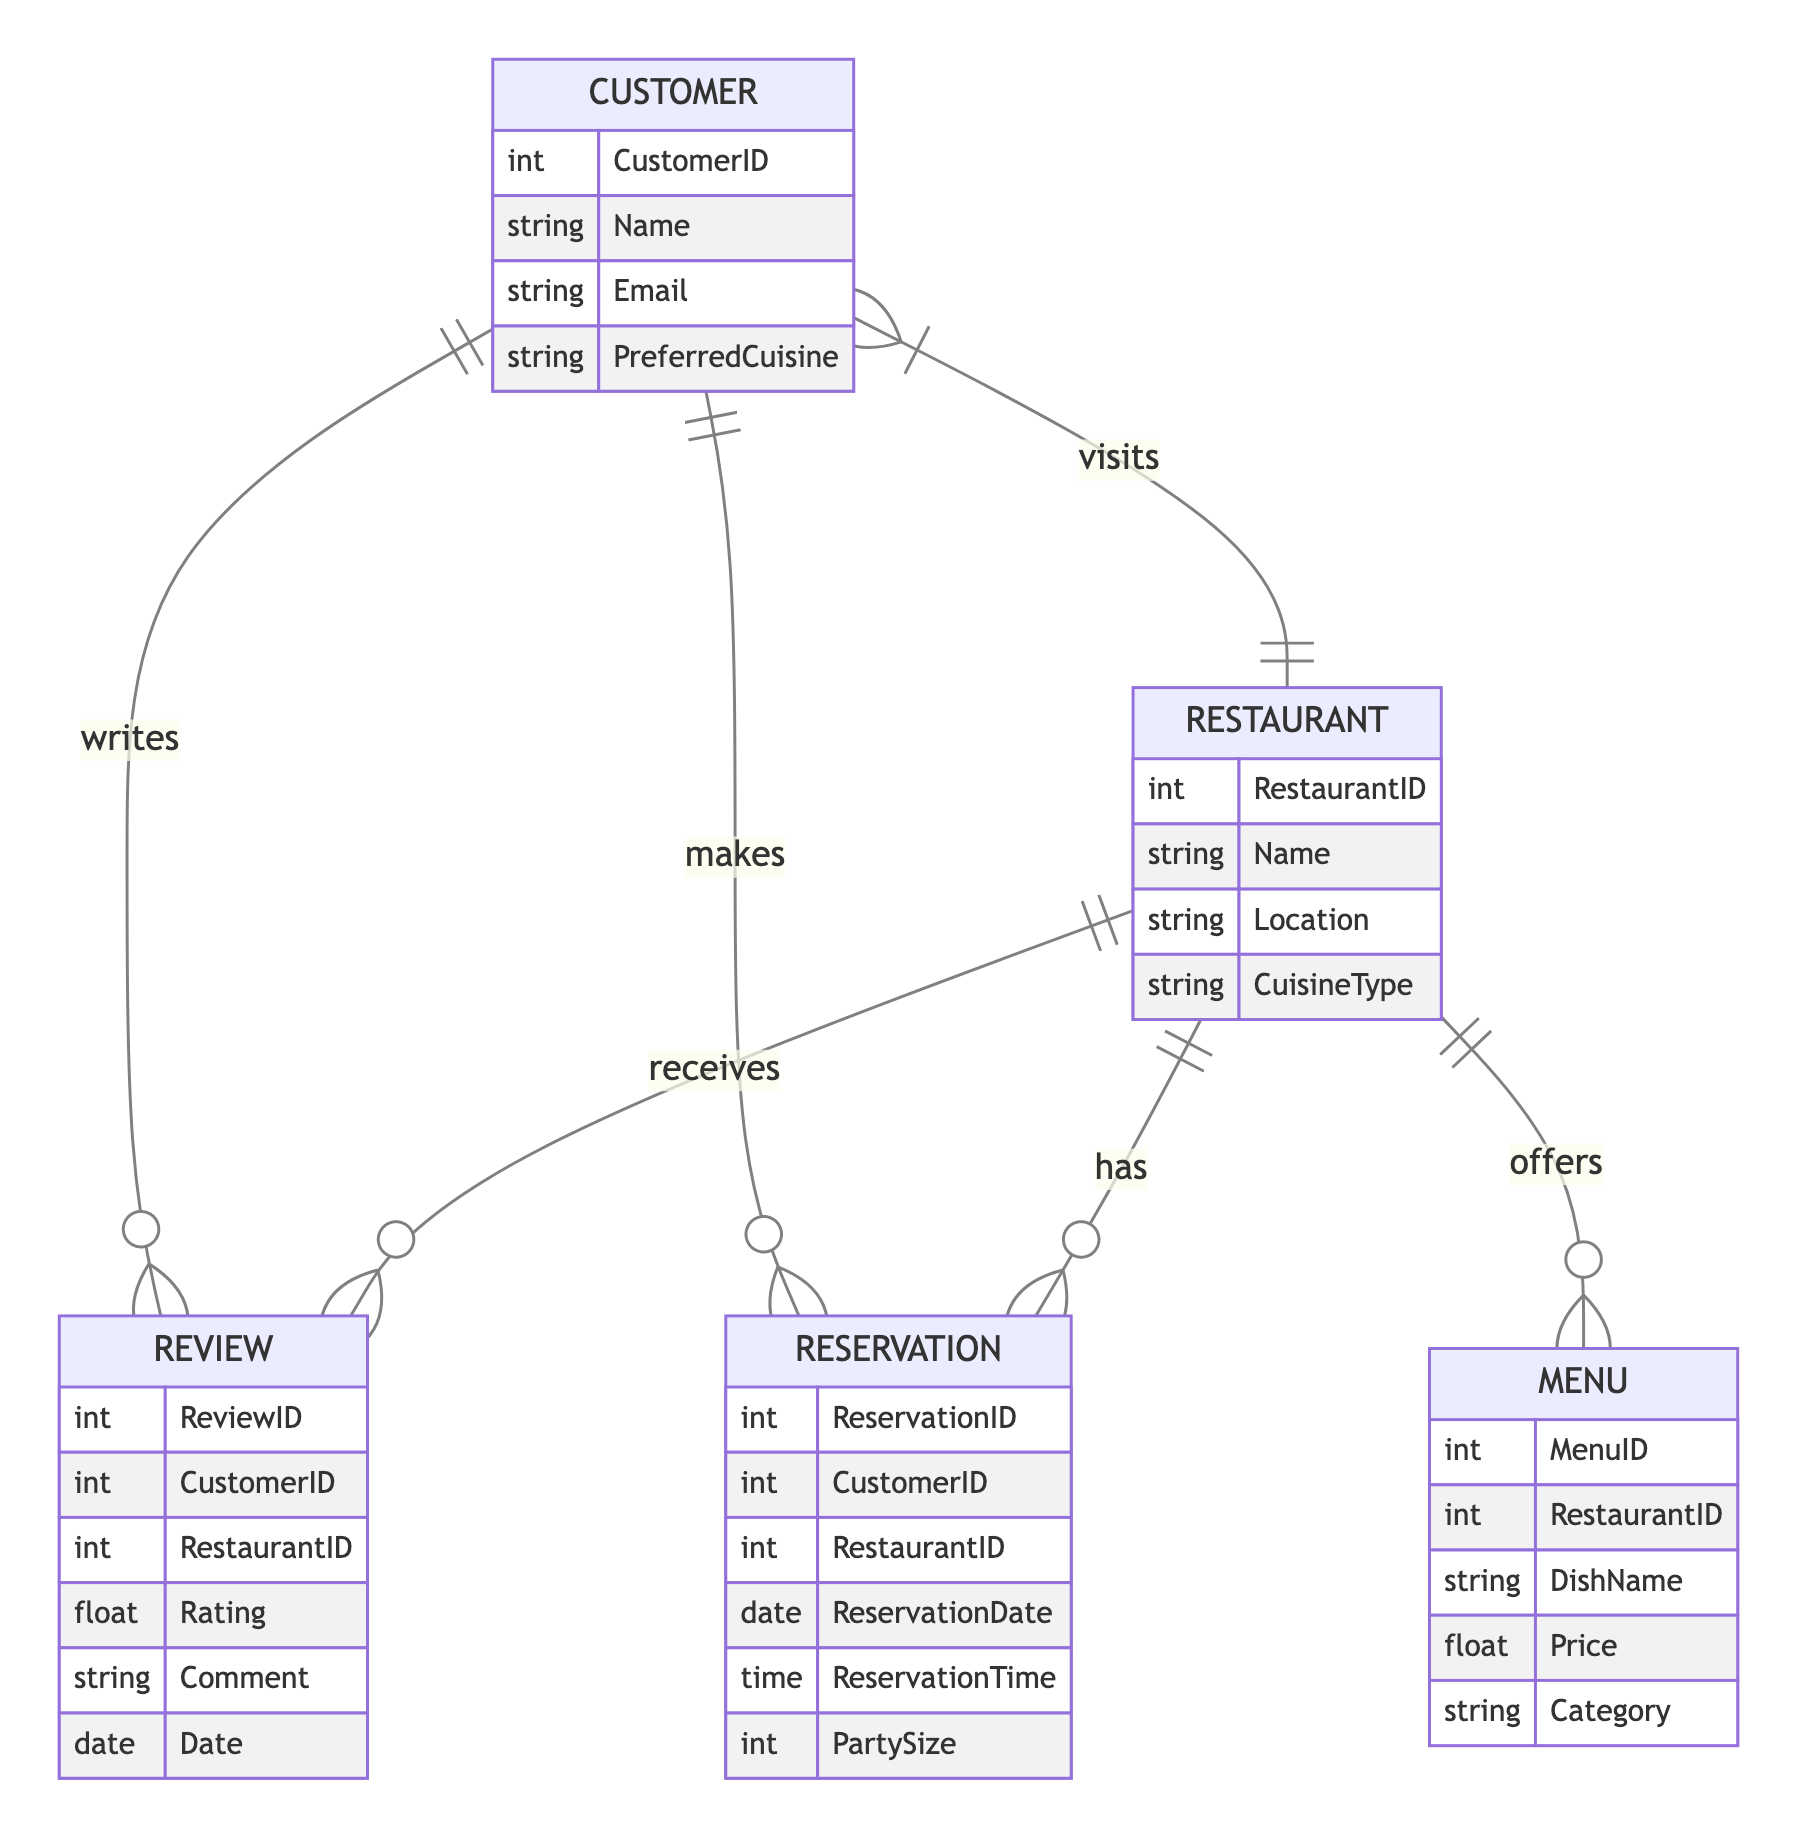What is the cardinality of the relationship between Customer and Review? The relationship between Customer and Review is represented with the notation "1:M". This indicates that one customer can write many reviews, but each review is written by one customer only.
Answer: 1:M Who can write reviews in this diagram? The entity that can write reviews is the Customer, as indicated by the relationship where the Customer "writes" the Review. This relationship captures the action of customers providing feedback on their restaurant experiences.
Answer: Customer How many attributes does the Restaurant entity have? The Restaurant entity has four specified attributes: RestaurantID, Name, Location, and CuisineType. To determine this, you can simply count the listed attributes under the Restaurant entity in the diagram.
Answer: 4 What is the relationship type between Customer and Restaurant? The relationship between Customer and Restaurant is labeled as "visits," which is represented as "M:N". This means that a customer can visit many restaurants, and restaurants can be visited by many customers as well.
Answer: M:N Which entity is associated with the Menu entity? The entity associated with the Menu is the Restaurant, as the diagram shows that a Restaurant "offers" a Menu. This relationship signifies that each restaurant provides its menu items to customers.
Answer: Restaurant How many types of entities are present in this diagram? The diagram contains five distinct entities: Customer, Restaurant, Review, Menu, and Reservation. To find this, simply count the unique entities listed.
Answer: 5 What can customers do related to reservations? Customers can "make" reservations, as indicated in the diagram where the relationship points from Customer to Reservation. This action shows that customers can book a table at restaurants through reservations.
Answer: Make What does the Menu entity represent? The Menu entity represents the dishes offered by a particular restaurant, including attributes like DishName and Price. This entity serves to detail what items are available for customers at their chosen restaurant.
Answer: Dishes offered Which relationship involves both Reservation and Restaurant? The relationship that involves both Reservation and Restaurant is labeled as "has." This indicates that a restaurant can have multiple reservations made by customers, showcasing availability for booking.
Answer: Has 